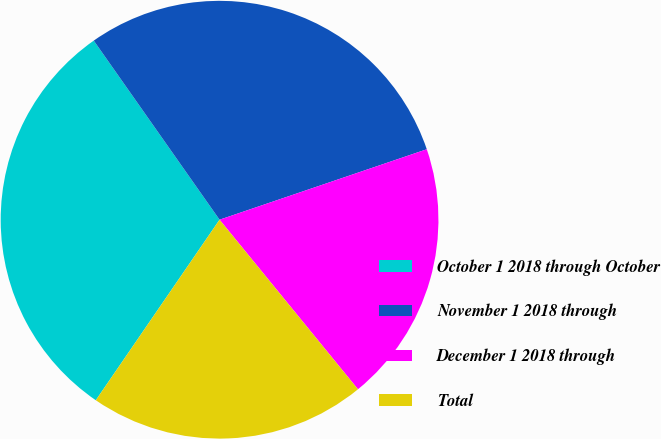Convert chart. <chart><loc_0><loc_0><loc_500><loc_500><pie_chart><fcel>October 1 2018 through October<fcel>November 1 2018 through<fcel>December 1 2018 through<fcel>Total<nl><fcel>30.69%<fcel>29.53%<fcel>19.32%<fcel>20.46%<nl></chart> 